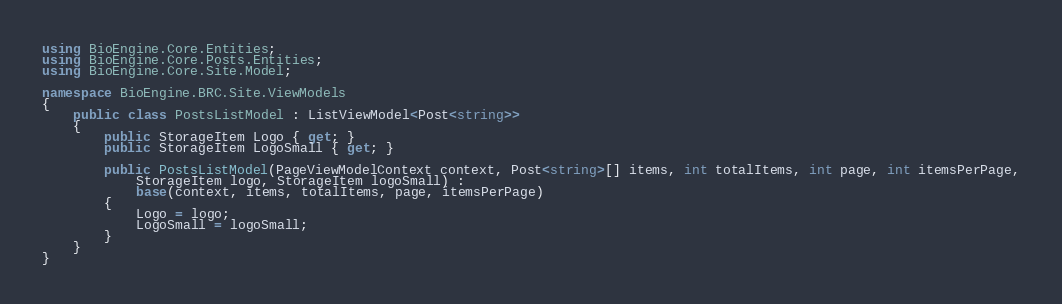<code> <loc_0><loc_0><loc_500><loc_500><_C#_>using BioEngine.Core.Entities;
using BioEngine.Core.Posts.Entities;
using BioEngine.Core.Site.Model;

namespace BioEngine.BRC.Site.ViewModels
{
    public class PostsListModel : ListViewModel<Post<string>>
    {
        public StorageItem Logo { get; }
        public StorageItem LogoSmall { get; }

        public PostsListModel(PageViewModelContext context, Post<string>[] items, int totalItems, int page, int itemsPerPage,
            StorageItem logo, StorageItem logoSmall) :
            base(context, items, totalItems, page, itemsPerPage)
        {
            Logo = logo;
            LogoSmall = logoSmall;
        }
    }
}
</code> 